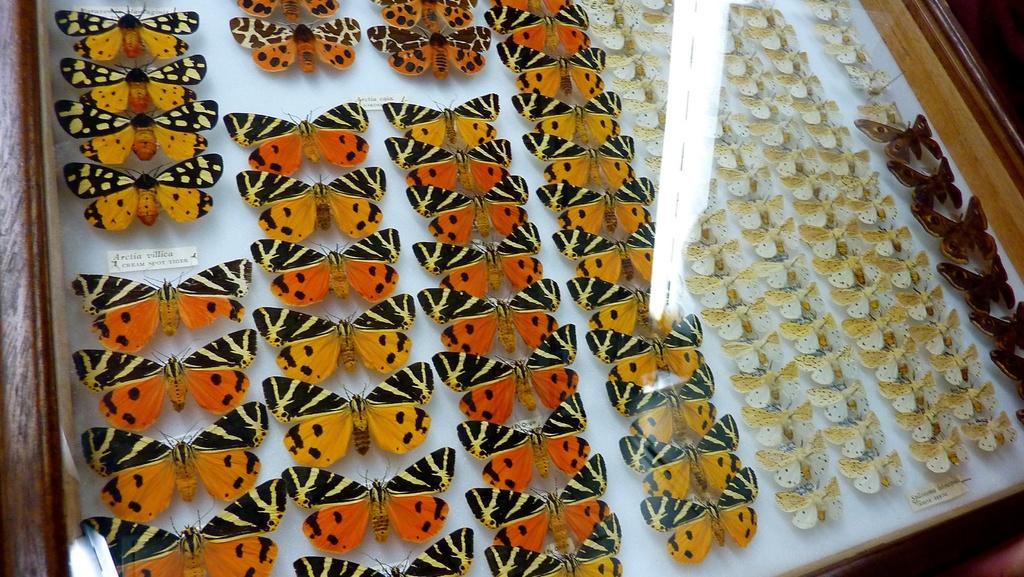In one or two sentences, can you explain what this image depicts? We can see different types of butterflies inside a glass box. 